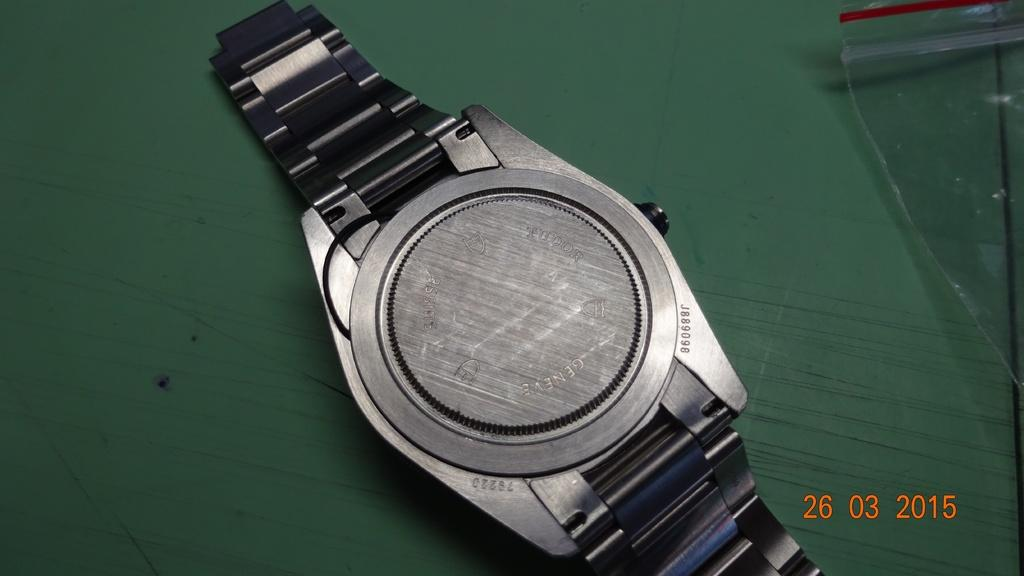<image>
Create a compact narrative representing the image presented. The back side of a watch taken on the 26 03 2015 